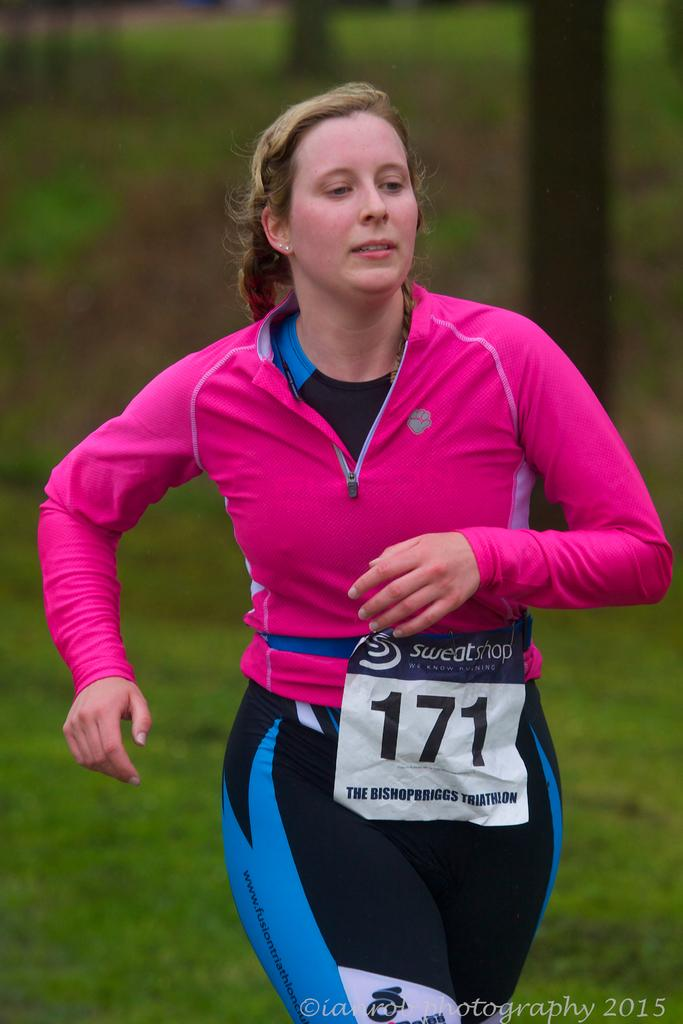Who is the main subject in the image? There is a woman in the image. What can be observed about the background of the image? The background of the image is blurred. What type of natural environment is visible in the background? There is greenery visible in the background of the image. What type of condition does the woman have in the image? There is no indication of any medical condition in the image; it simply shows a woman in an unspecified setting. What is the end result of the woman's actions in the image? The image does not depict any actions or events that have a clear end result. 